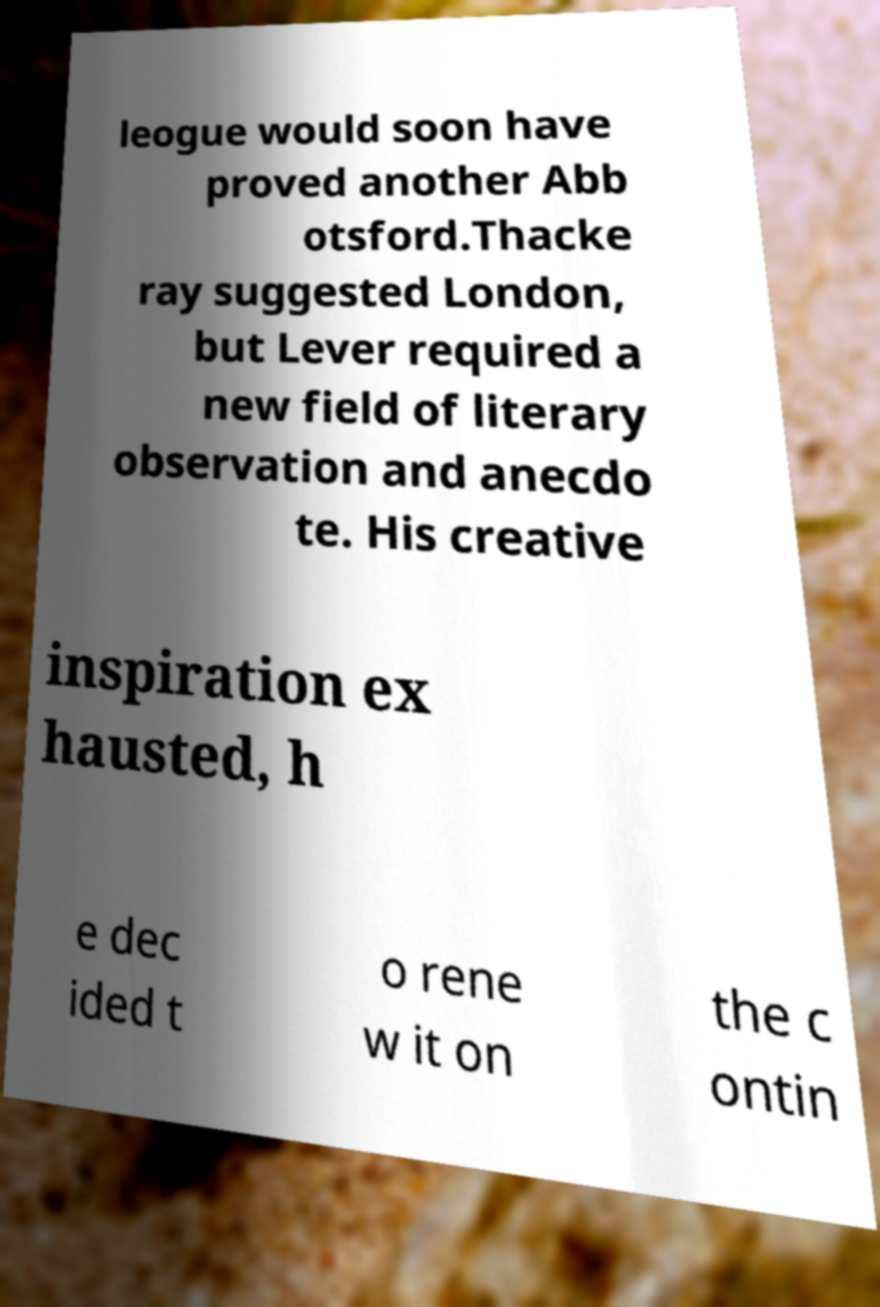Can you accurately transcribe the text from the provided image for me? leogue would soon have proved another Abb otsford.Thacke ray suggested London, but Lever required a new field of literary observation and anecdo te. His creative inspiration ex hausted, h e dec ided t o rene w it on the c ontin 